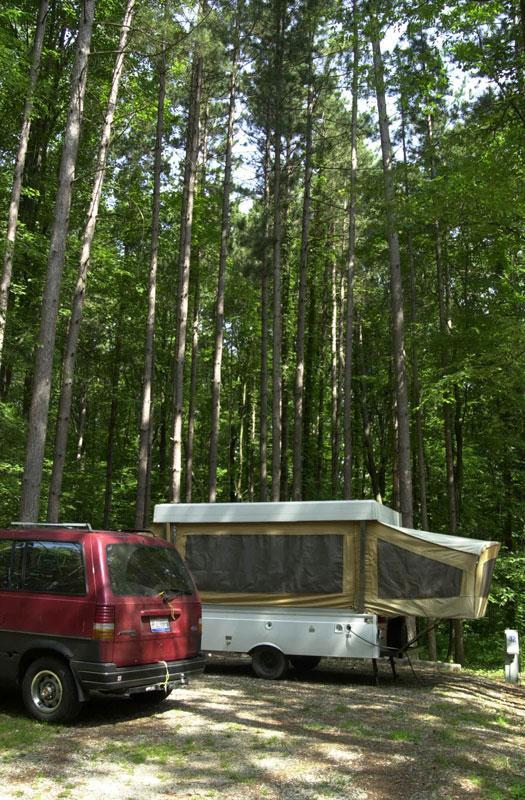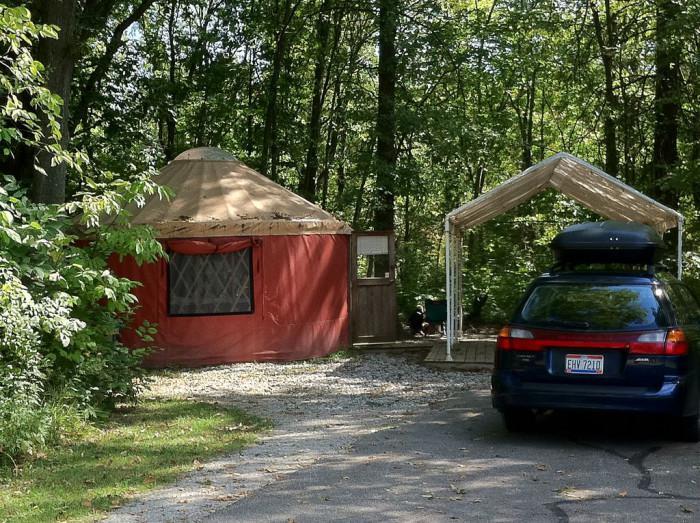The first image is the image on the left, the second image is the image on the right. Analyze the images presented: Is the assertion "The left image contains a cottage surrounded by a wooden railing." valid? Answer yes or no. No. The first image is the image on the left, the second image is the image on the right. For the images shown, is this caption "An image shows a green yurt with a pale roof, and it is surrounded by a square railed deck." true? Answer yes or no. No. 